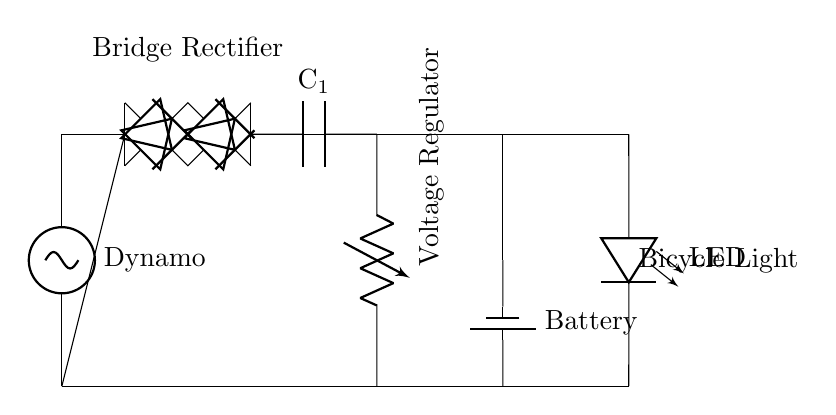What component generates electrical power? The dynamo is the source of electrical power in the circuit, converting mechanical energy from pedaling into electrical energy.
Answer: Dynamo What is the purpose of the bridge rectifier? The bridge rectifier converts alternating current produced by the dynamo into direct current, which is necessary for charging the battery and powering the LED.
Answer: Converts AC to DC What is the role of the smoothing capacitor? The smoothing capacitor (C1) reduces voltage fluctuations from the rectified output, providing a more stable DC voltage for the voltage regulator and battery.
Answer: Stabilizes voltage What type of battery is used in the circuit? The circuit uses a rechargeable battery, which stores electrical energy generated by the dynamo for later use to power the LED when needed.
Answer: Rechargeable battery How many LEDs are present in the circuit? There is one LED indicated in the circuit diagram, which is used for lighting purposes when powered by the battery.
Answer: One What is the output of the voltage regulator? The voltage regulator ensures that the output voltage to the LED and other components remains constant, protecting them from voltage spikes or drops from the dynamo.
Answer: Constant voltage How is the LED connected in the circuit? The LED is connected in parallel to the battery, allowing it to receive power from the battery to illuminate while the bicycle is in use.
Answer: In parallel 